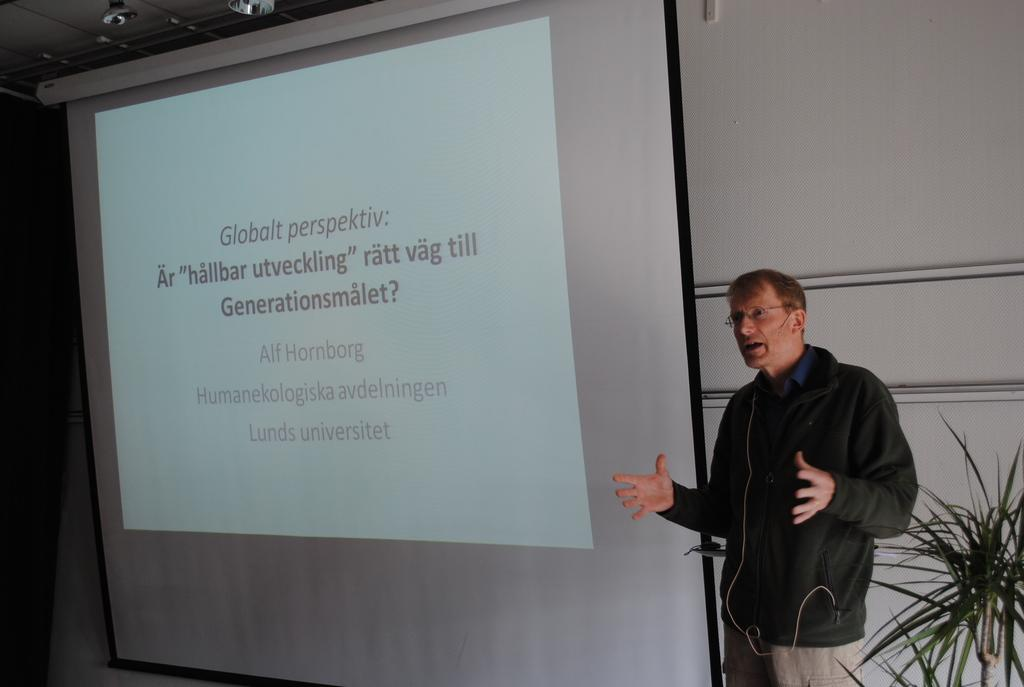Who is present in the image? There is a person in the image. What can be observed about the person's appearance? The person is wearing glasses. What is the person holding in the image? The person is holding a microphone. What type of plant is visible in the image? There is a houseplant in the image. What is displayed on the screen in the background? There is text visible on a screen in the background. What can be seen at the top of the image? There are lights at the top of the image. What type of brake is being used by the person in the image? There is no brake present in the image; it features a person holding a microphone and wearing glasses. Can you tell me how many donkeys are visible in the image? There are no donkeys present in the image. 